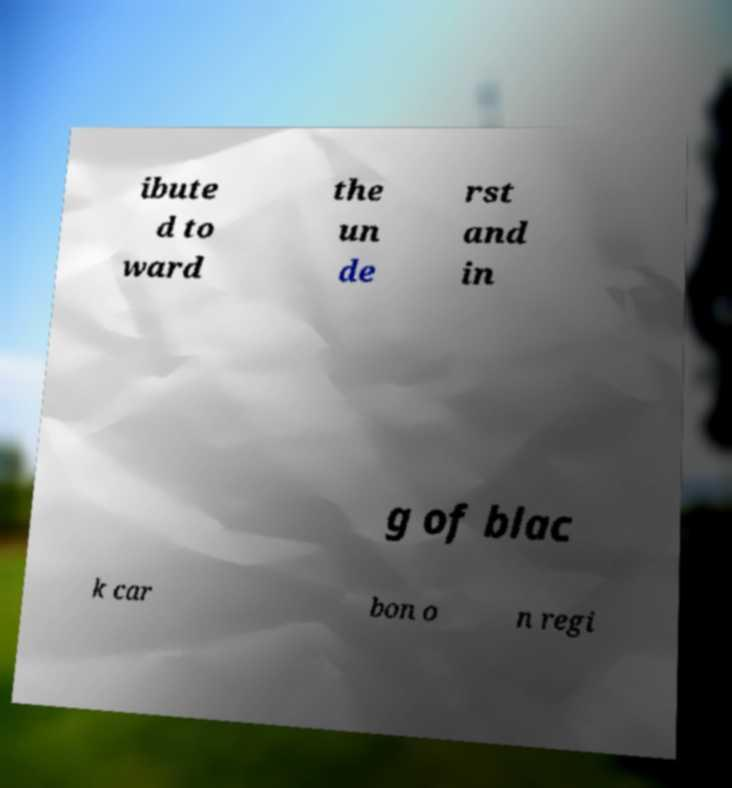Could you extract and type out the text from this image? ibute d to ward the un de rst and in g of blac k car bon o n regi 